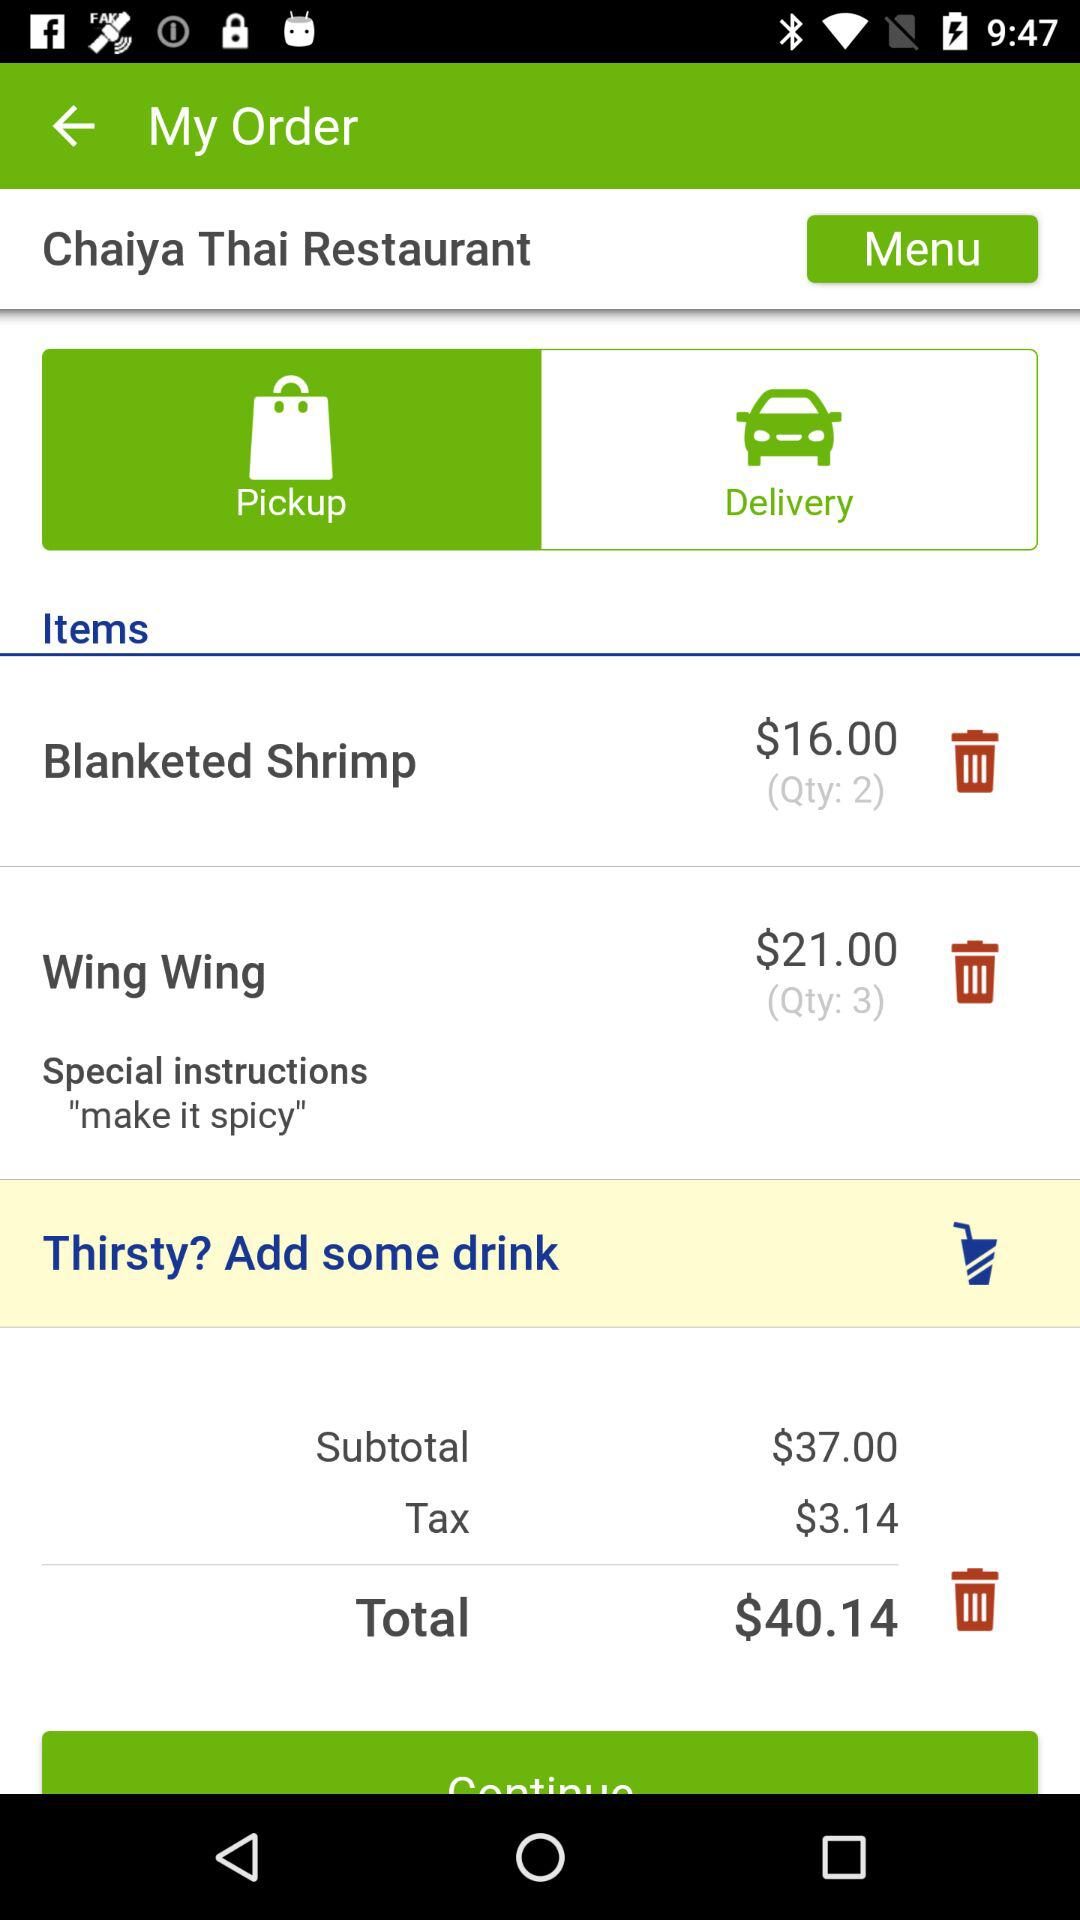Which tab is selected? The selected tab is "Pickup". 